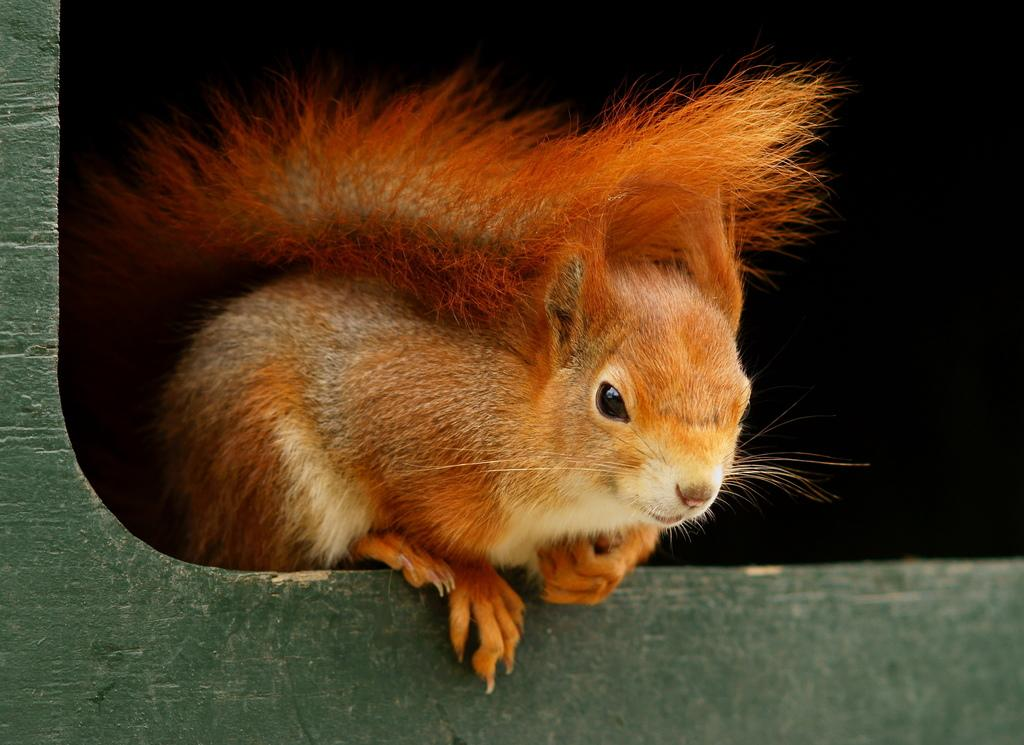What type of animal is in the image? There is a squirrel in the image. What is the squirrel doing or positioned on in the image? The squirrel is on an object. What color is the background of the image? The background of the image is black in color. What type of music is the squirrel playing in the image? There is no music or musical instrument present in the image; it features a squirrel on an object with a black background. 